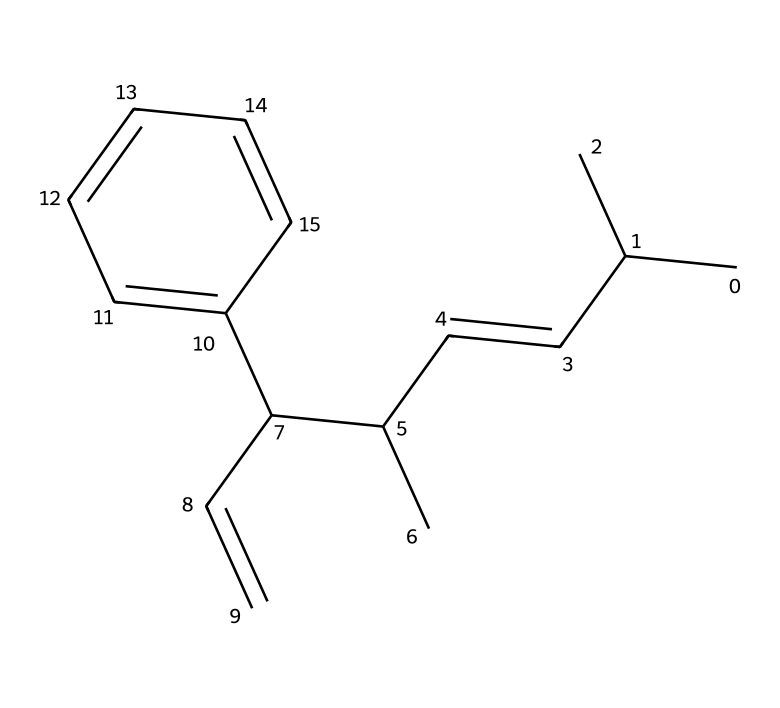What is the molecular formula for this chemical? To find the molecular formula, we need to count the number of each type of atom in the SMILES representation. The structure shows 15 carbon atoms and 18 hydrogen atoms. Therefore, the molecular formula is C15H18.
Answer: C15H18 How many rings are present in the structure? By analyzing the SMILES, there are no indications of any cyclic structures or rings, as it is primarily a linear alkene with a phenyl group. Thus, the number of rings is zero.
Answer: 0 What functional groups are present in the chemical? The SMILES indicates that there is an alkene group (due to the presence of a double bond) and a phenyl group. Therefore, the functional groups present are alkene and aromatic.
Answer: alkene and aromatic Is this chemical a polymer? The SMILES does not show repeating units, nor does it indicate a long-chain structure typical of polymers. It represents a single molecular entity. Thus, this chemical is not classified as a polymer.
Answer: No What type of reaction is likely involved in the formation of this compound? The presence of a double bond suggests that this compound may have been formed through processes such as alkylation or Diels-Alder reactions common in organic synthesis.
Answer: Alkylation or Diels-Alder Does this chemical contribute to the scent or flavor? Yes, being a part of the flavors and fragrances category, its aromatic characteristics contribute to scent and flavor profiles, which are employed in perfumes and food flavorings.
Answer: Yes 